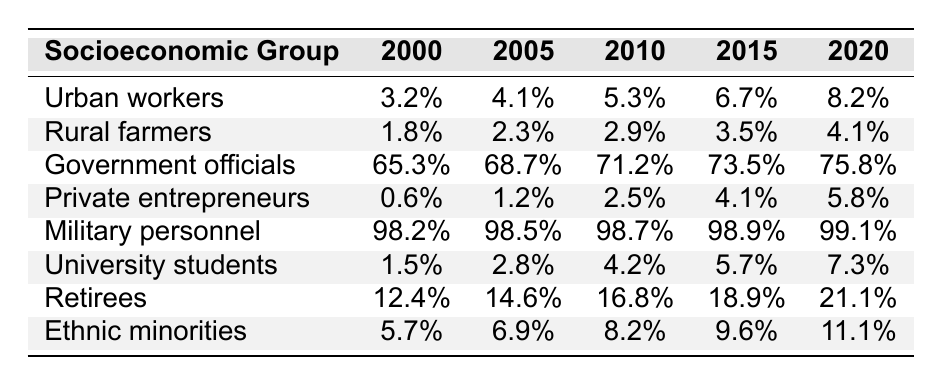What was the Party membership percentage among Urban workers in 2020? From the table, locate the row for Urban workers and find the value for the year 2020. The percentage given is 8.2%.
Answer: 8.2% Which socioeconomic group had the highest percentage of Party membership in 2000? Looking at the 2000 column, the highest percentage is 98.2% for Military personnel.
Answer: Military personnel What is the increase in Party membership percentage for Government officials from 2000 to 2020? Calculate the difference between the values for Government officials in 2020 and 2000. This is 75.8% - 65.3% = 10.5%.
Answer: 10.5% Which group had the lowest Party membership in 2015? Check the 2015 column for the lowest value. The lowest percentage is 4.1% for Rural farmers.
Answer: Rural farmers Find the average Party membership percentage among University students over the years recorded. Add the five years' percentages for University students: (1.5 + 2.8 + 4.2 + 5.7 + 7.3 = 21.5%), then divide by 5 (21.5%/5 = 4.3%).
Answer: 4.3% Did Private entrepreneurs see an increase in Party membership from 2010 to 2015? Compare the percentages for Private entrepreneurs in 2010 (2.5%) and 2015 (4.1%). 4.1% is greater than 2.5%, indicating an increase.
Answer: Yes What percentage of Retirees were Party members in 2000 and how much has it grown by 2020? The percentage for Retirees in 2000 is 12.4% and in 2020 it is 21.1%. The growth is 21.1% - 12.4% = 8.7%.
Answer: 8.7% If you sum the Party membership percentages of Urban workers and Private entrepreneurs for the year 2010, what is the total? Add the respective values: 5.3% (Urban workers) + 2.5% (Private entrepreneurs) = 7.8%.
Answer: 7.8% Is the Party membership percentage for Ethnic minorities increasing consistently from 2000 to 2020? Review the yearly percentages: 5.7%, 6.9%, 8.2%, 9.6%, and 11.1%. All values show an increase year over year.
Answer: Yes What is the difference in Party membership percentage between University students and Rural farmers in 2020? In 2020, University students have 7.3% and Rural farmers have 4.1%. The difference is 7.3% - 4.1% = 3.2%.
Answer: 3.2% 